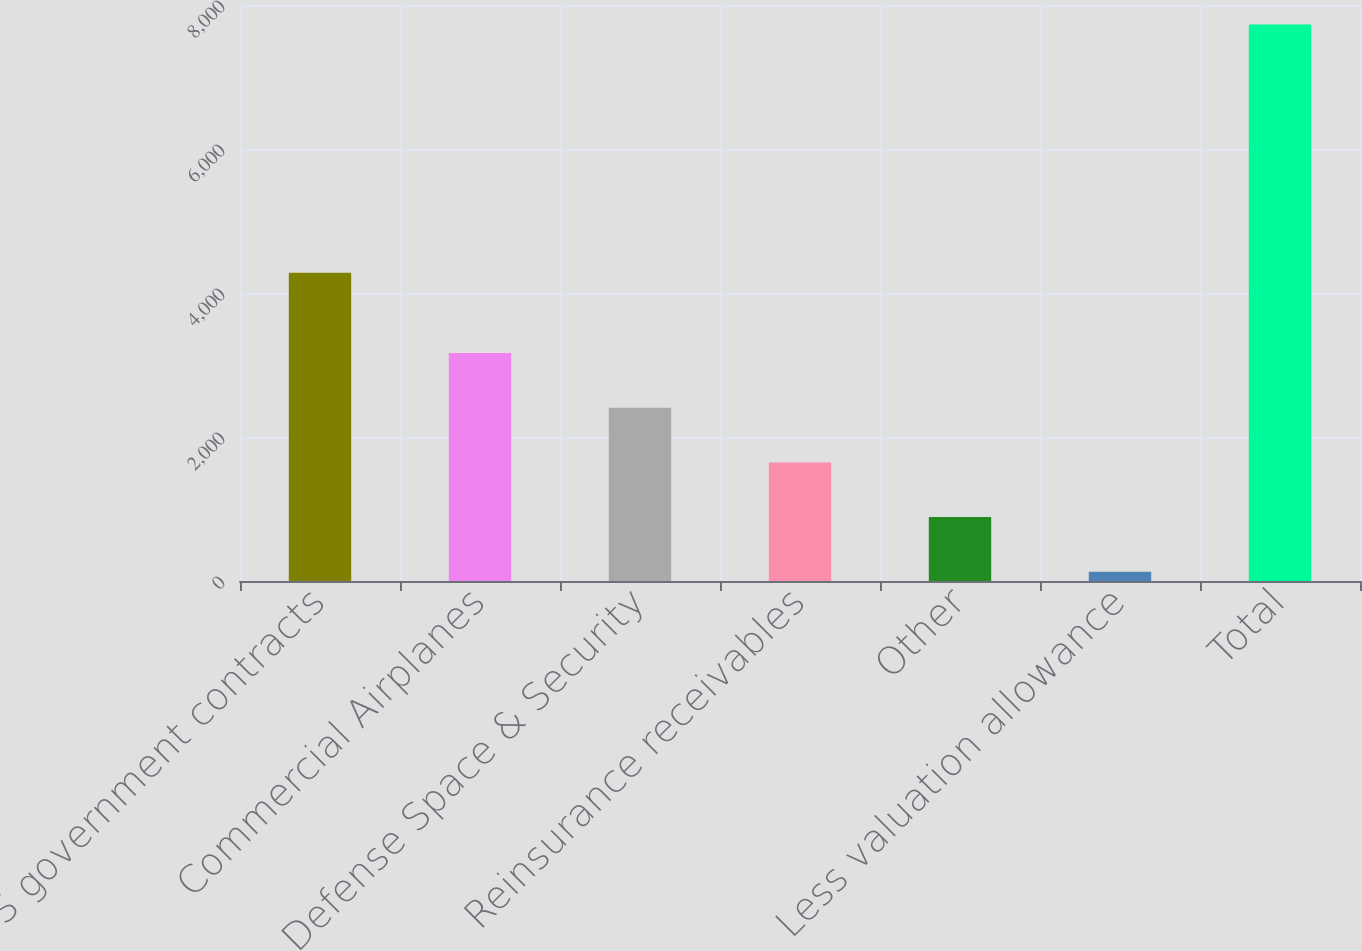Convert chart to OTSL. <chart><loc_0><loc_0><loc_500><loc_500><bar_chart><fcel>US government contracts<fcel>Commercial Airplanes<fcel>Defense Space & Security<fcel>Reinsurance receivables<fcel>Other<fcel>Less valuation allowance<fcel>Total<nl><fcel>4281<fcel>3167.8<fcel>2407.6<fcel>1647.4<fcel>887.2<fcel>127<fcel>7729<nl></chart> 